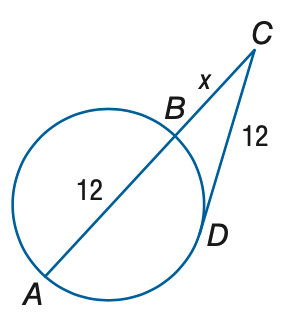Answer the mathemtical geometry problem and directly provide the correct option letter.
Question: Find x to the nearest tenth. Assume that segments that appear to be tangent are tangent.
Choices: A: 7.4 B: 7.9 C: 8.4 D: 8.9 A 